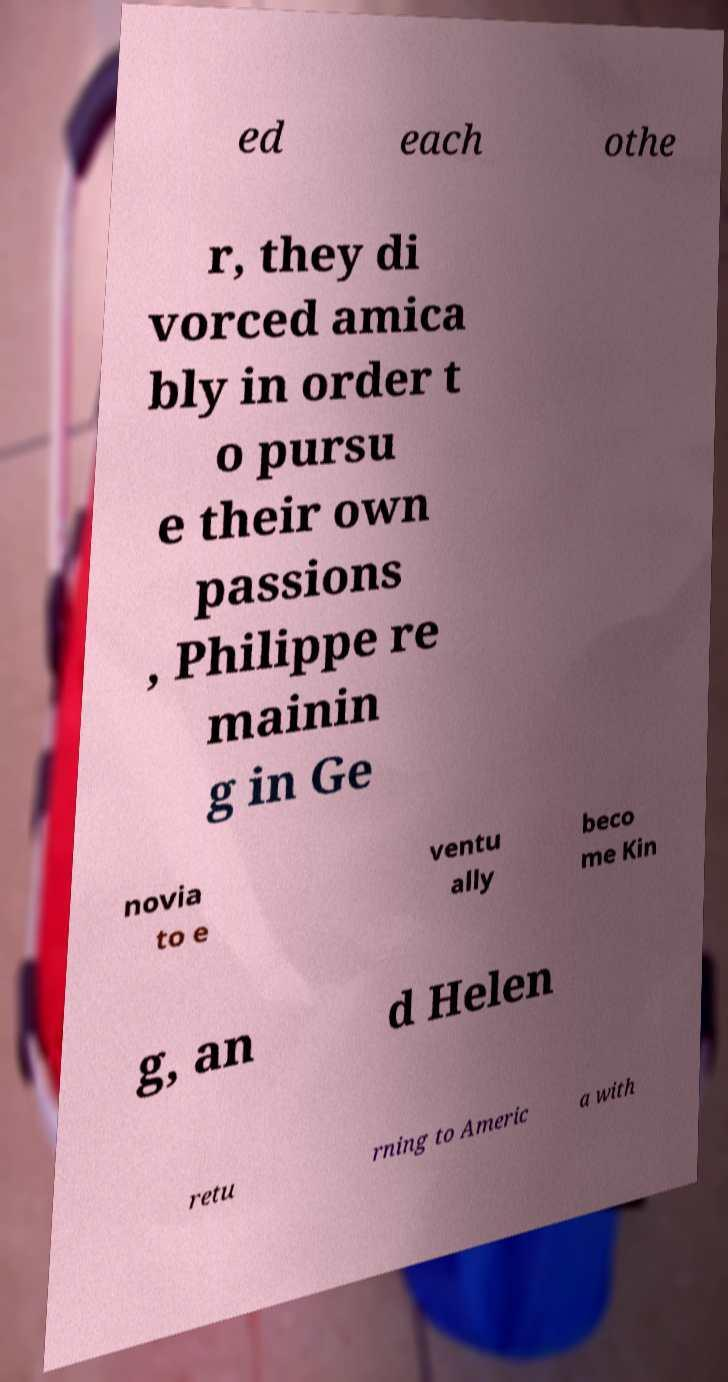I need the written content from this picture converted into text. Can you do that? ed each othe r, they di vorced amica bly in order t o pursu e their own passions , Philippe re mainin g in Ge novia to e ventu ally beco me Kin g, an d Helen retu rning to Americ a with 